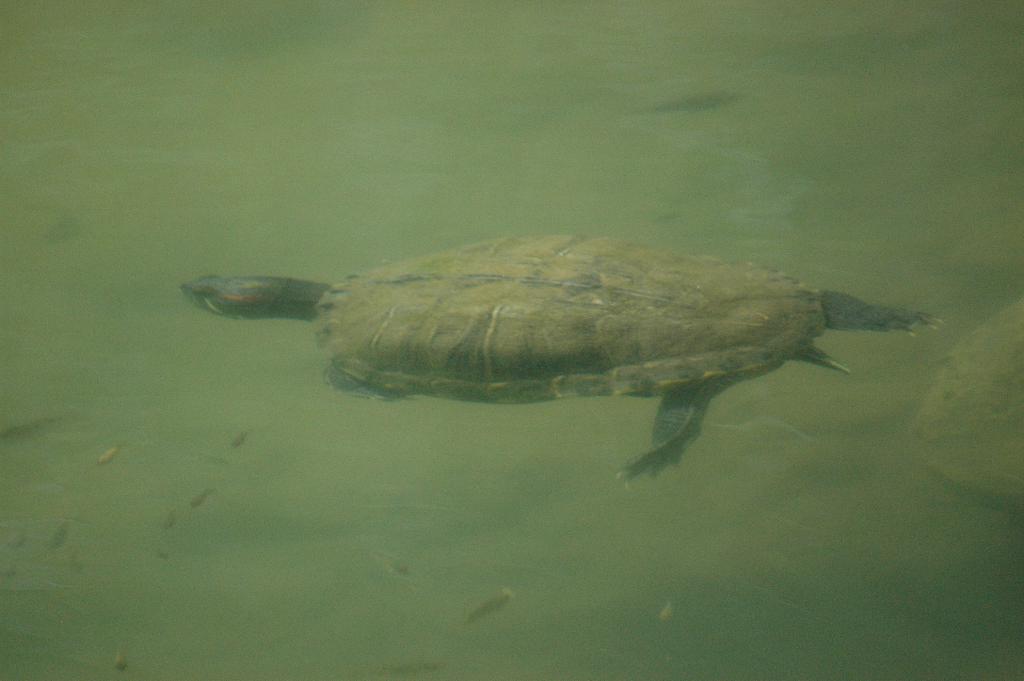Could you give a brief overview of what you see in this image? In this image, I can see a turtle in the water These are the tiny fishes. This water looks green in color. 